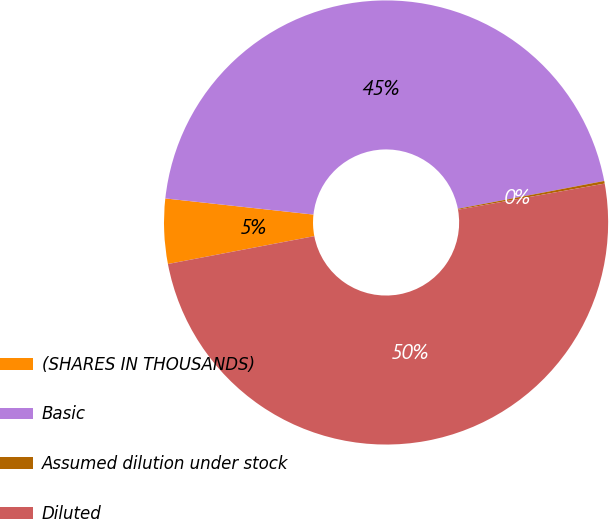<chart> <loc_0><loc_0><loc_500><loc_500><pie_chart><fcel>(SHARES IN THOUSANDS)<fcel>Basic<fcel>Assumed dilution under stock<fcel>Diluted<nl><fcel>4.72%<fcel>45.28%<fcel>0.19%<fcel>49.81%<nl></chart> 